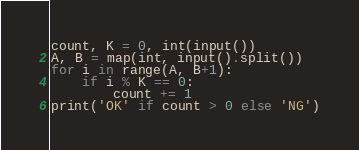<code> <loc_0><loc_0><loc_500><loc_500><_Python_>count, K = 0, int(input())
A, B = map(int, input().split())
for i in range(A, B+1):
    if i % K == 0:
        count += 1
print('OK' if count > 0 else 'NG')</code> 